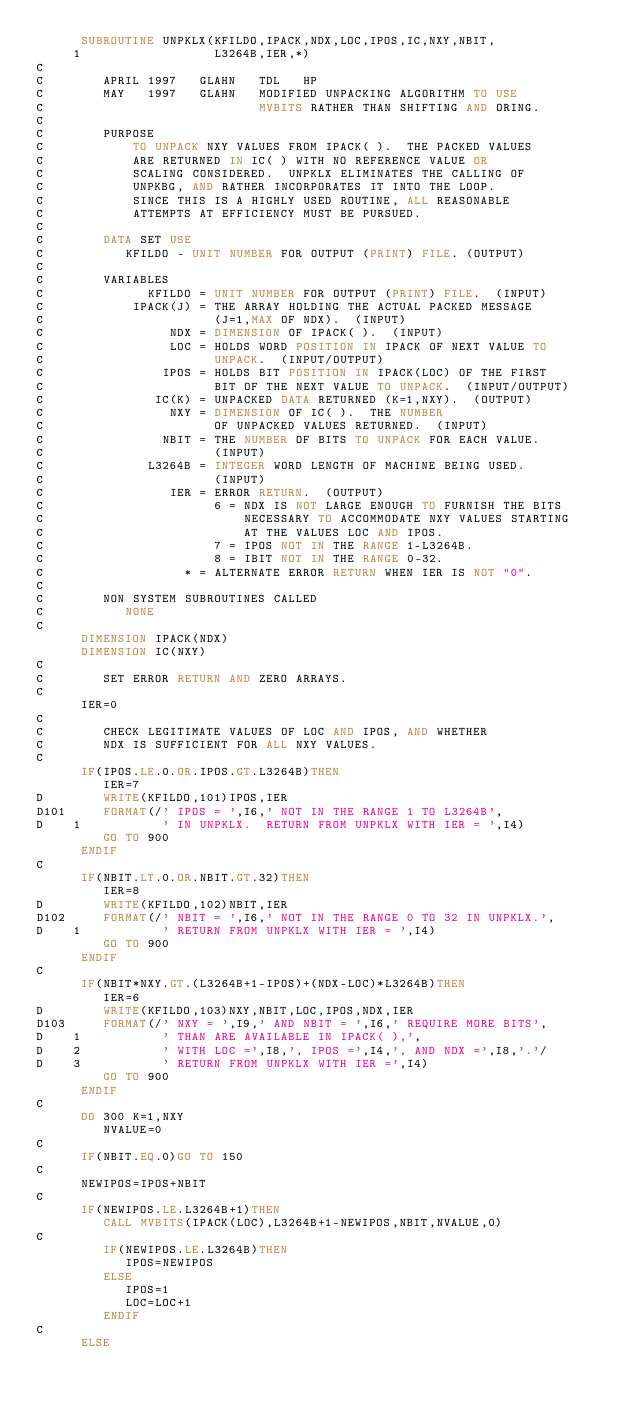<code> <loc_0><loc_0><loc_500><loc_500><_FORTRAN_>      SUBROUTINE UNPKLX(KFILDO,IPACK,NDX,LOC,IPOS,IC,NXY,NBIT,
     1                  L3264B,IER,*)
C
C        APRIL 1997   GLAHN   TDL   HP
C        MAY   1997   GLAHN   MODIFIED UNPACKING ALGORITHM TO USE
C                             MVBITS RATHER THAN SHIFTING AND ORING.
C
C        PURPOSE 
C            TO UNPACK NXY VALUES FROM IPACK( ).  THE PACKED VALUES
C            ARE RETURNED IN IC( ) WITH NO REFERENCE VALUE OR 
C            SCALING CONSIDERED.  UNPKLX ELIMINATES THE CALLING OF
C            UNPKBG, AND RATHER INCORPORATES IT INTO THE LOOP.
C            SINCE THIS IS A HIGHLY USED ROUTINE, ALL REASONABLE
C            ATTEMPTS AT EFFICIENCY MUST BE PURSUED.
C
C        DATA SET USE 
C           KFILDO - UNIT NUMBER FOR OUTPUT (PRINT) FILE. (OUTPUT) 
C
C        VARIABLES 
C              KFILDO = UNIT NUMBER FOR OUTPUT (PRINT) FILE.  (INPUT) 
C            IPACK(J) = THE ARRAY HOLDING THE ACTUAL PACKED MESSAGE
C                       (J=1,MAX OF NDX).  (INPUT)
C                 NDX = DIMENSION OF IPACK( ).  (INPUT)
C                 LOC = HOLDS WORD POSITION IN IPACK OF NEXT VALUE TO
C                       UNPACK.  (INPUT/OUTPUT)
C                IPOS = HOLDS BIT POSITION IN IPACK(LOC) OF THE FIRST
C                       BIT OF THE NEXT VALUE TO UNPACK.  (INPUT/OUTPUT)
C               IC(K) = UNPACKED DATA RETURNED (K=1,NXY).  (OUTPUT)
C                 NXY = DIMENSION OF IC( ).  THE NUMBER
C                       OF UNPACKED VALUES RETURNED.  (INPUT)
C                NBIT = THE NUMBER OF BITS TO UNPACK FOR EACH VALUE.
C                       (INPUT)
C              L3264B = INTEGER WORD LENGTH OF MACHINE BEING USED.
C                       (INPUT)
C                 IER = ERROR RETURN.  (OUTPUT)
C                       6 = NDX IS NOT LARGE ENOUGH TO FURNISH THE BITS
C                           NECESSARY TO ACCOMMODATE NXY VALUES STARTING
C                           AT THE VALUES LOC AND IPOS.
C                       7 = IPOS NOT IN THE RANGE 1-L3264B.
C                       8 = IBIT NOT IN THE RANGE 0-32.
C                   * = ALTERNATE ERROR RETURN WHEN IER IS NOT "0".
C
C        NON SYSTEM SUBROUTINES CALLED 
C           NONE
C
      DIMENSION IPACK(NDX)
      DIMENSION IC(NXY)
C
C        SET ERROR RETURN AND ZERO ARRAYS.
C
      IER=0
C
C        CHECK LEGITIMATE VALUES OF LOC AND IPOS, AND WHETHER
C        NDX IS SUFFICIENT FOR ALL NXY VALUES.
C
      IF(IPOS.LE.0.OR.IPOS.GT.L3264B)THEN
         IER=7
D        WRITE(KFILDO,101)IPOS,IER
D101     FORMAT(/' IPOS = ',I6,' NOT IN THE RANGE 1 TO L3264B',
D    1           ' IN UNPKLX.  RETURN FROM UNPKLX WITH IER = ',I4)
         GO TO 900 
      ENDIF
C
      IF(NBIT.LT.0.OR.NBIT.GT.32)THEN
         IER=8
D        WRITE(KFILDO,102)NBIT,IER
D102     FORMAT(/' NBIT = ',I6,' NOT IN THE RANGE 0 TO 32 IN UNPKLX.',
D    1           ' RETURN FROM UNPKLX WITH IER = ',I4)
         GO TO 900
      ENDIF
C
      IF(NBIT*NXY.GT.(L3264B+1-IPOS)+(NDX-LOC)*L3264B)THEN
         IER=6
D        WRITE(KFILDO,103)NXY,NBIT,LOC,IPOS,NDX,IER
D103     FORMAT(/' NXY = ',I9,' AND NBIT = ',I6,' REQUIRE MORE BITS',
D    1           ' THAN ARE AVAILABLE IN IPACK( ),',
D    2           ' WITH LOC =',I8,', IPOS =',I4,', AND NDX =',I8,'.'/
D    3           ' RETURN FROM UNPKLX WITH IER =',I4)
         GO TO 900
      ENDIF
C      
      DO 300 K=1,NXY 
         NVALUE=0
C
      IF(NBIT.EQ.0)GO TO 150
C   
      NEWIPOS=IPOS+NBIT
C
      IF(NEWIPOS.LE.L3264B+1)THEN
         CALL MVBITS(IPACK(LOC),L3264B+1-NEWIPOS,NBIT,NVALUE,0)
C
         IF(NEWIPOS.LE.L3264B)THEN
            IPOS=NEWIPOS
         ELSE
            IPOS=1
            LOC=LOC+1
         ENDIF
C
      ELSE</code> 